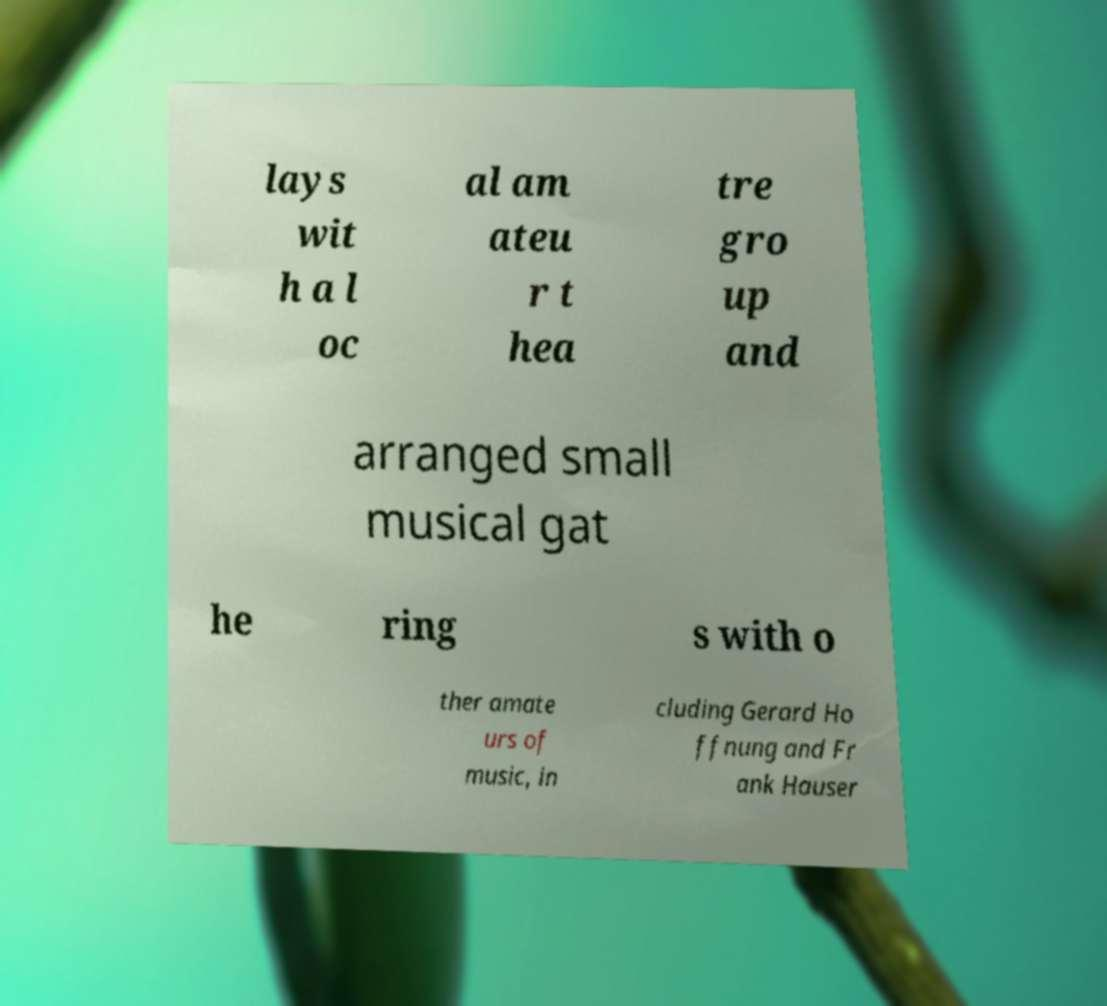What messages or text are displayed in this image? I need them in a readable, typed format. lays wit h a l oc al am ateu r t hea tre gro up and arranged small musical gat he ring s with o ther amate urs of music, in cluding Gerard Ho ffnung and Fr ank Hauser 